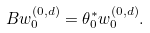Convert formula to latex. <formula><loc_0><loc_0><loc_500><loc_500>B w ^ { ( 0 , d ) } _ { 0 } = \theta _ { 0 } ^ { * } w ^ { ( 0 , d ) } _ { 0 } .</formula> 